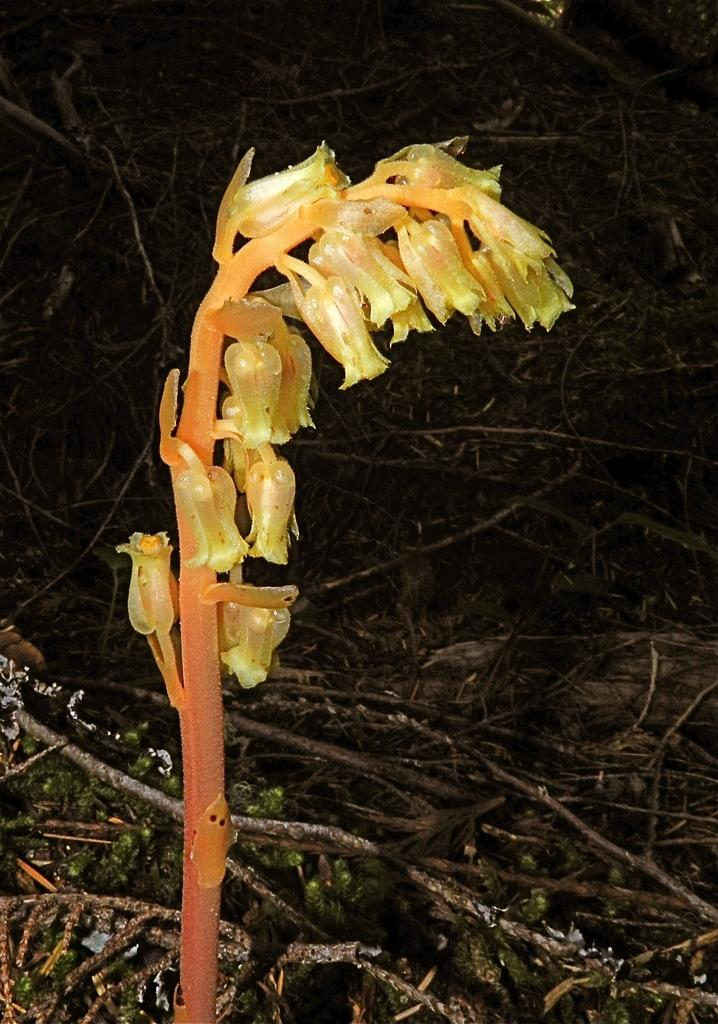What is the main subject of the image? The main subject of the image is a flower. Can you describe the colors of the flower? The flower has cream, yellow, and orange colors. What else can be seen in the image besides the flower petals? There are stems visible in the image. What is the color of the background in the image? The background of the image is dark. Can you tell me how many pigs are visible in the image? There are no pigs present in the image; it features a flower with stems and a dark background. What type of brake system is used on the carriage in the image? There is no carriage or brake system present in the image. 